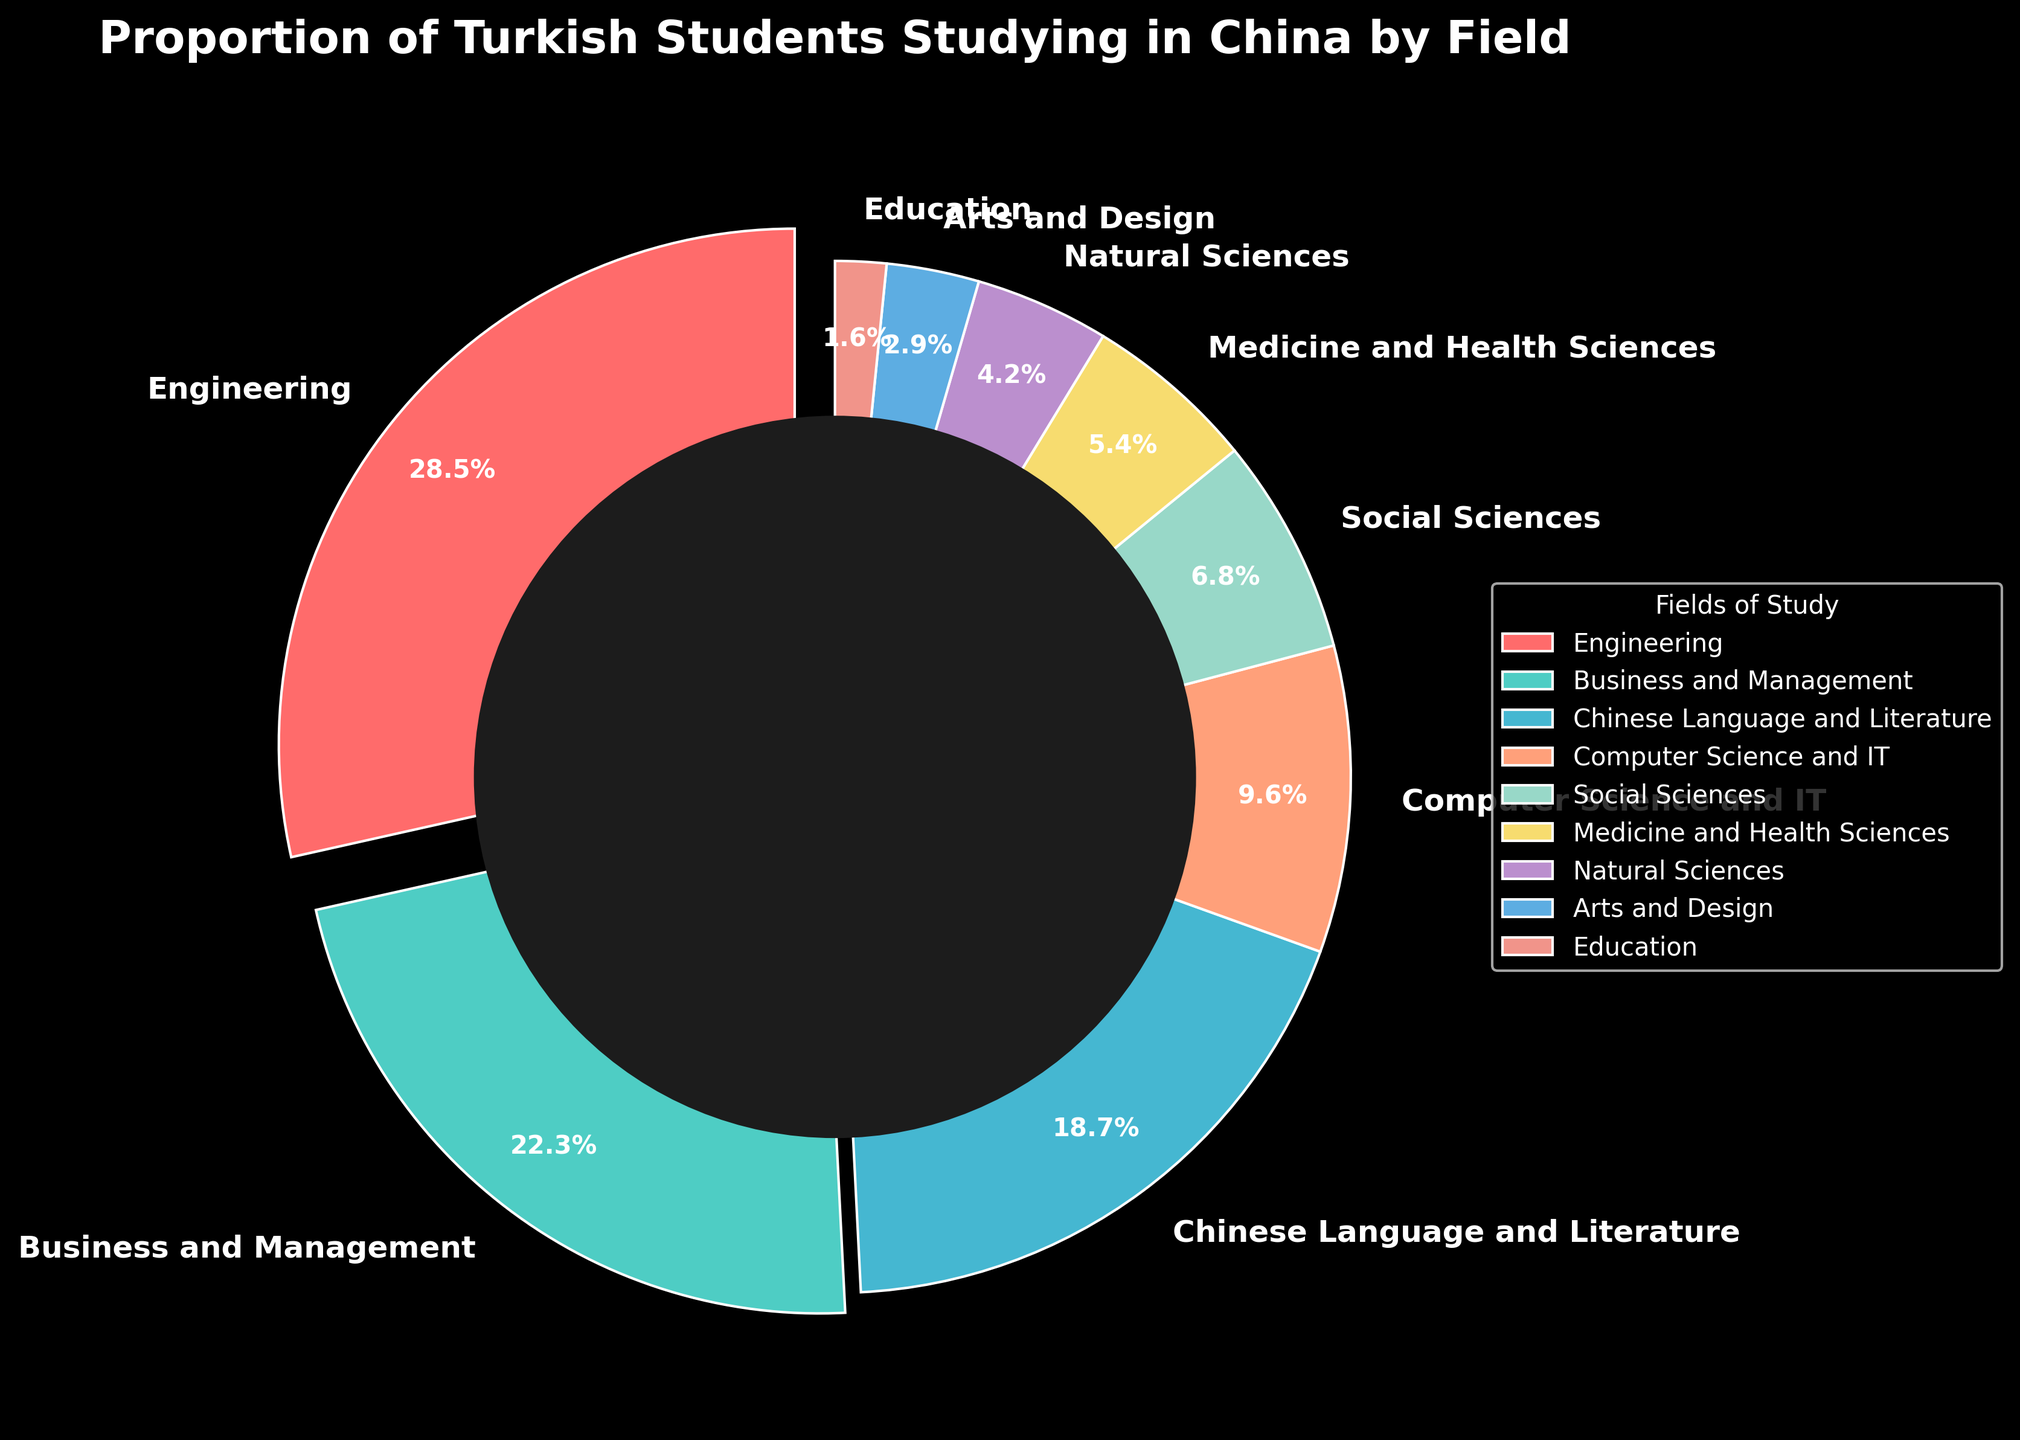Which field of study has the highest proportion of Turkish students studying in China? From the pie chart, the field with the largest wedge is labeled "Engineering" with a percentage of 28.5%.
Answer: Engineering What is the combined proportion of Turkish students studying Business and Management and Chinese Language and Literature in China? The proportions for Business and Management and Chinese Language and Literature are 22.3% and 18.7%, respectively. Adding them up: 22.3 + 18.7 = 41.0%.
Answer: 41.0% Which field has a smaller proportion of students: Medicine and Health Sciences or Social Sciences? From the pie chart, Social Sciences is 6.8% while Medicine and Health Sciences is 5.4%. Since 5.4% < 6.8%, Medicine and Health Sciences has a smaller proportion.
Answer: Medicine and Health Sciences How much larger is the proportion of students studying Engineering than the proportion studying Natural Sciences? The proportion of students in Engineering is 28.5% and in Natural Sciences is 4.2%. The difference is 28.5 - 4.2 = 24.3%.
Answer: 24.3% If a third of the students studying Engineering switched to Computer Science and IT, what would the new proportions for these two fields be? A third of Engineering's 28.5% is (1/3)*28.5 = 9.5%. Removing this from Engineering: 28.5 - 9.5 = 19.0%. Adding this to Computer Science and IT: 9.6 + 9.5 = 19.1%.
Answer: Engineering: 19.0%, Computer Science and IT: 19.1% What is the total proportion of Turkish students studying in the top three fields in China? The top three fields are Engineering (28.5%), Business and Management (22.3%), and Chinese Language and Literature (18.7%). Adding these proportions: 28.5 + 22.3 + 18.7 = 69.5%.
Answer: 69.5% Which wedge in the pie chart is displayed with a different starting angle or an additional visual effect? The largest wedge, which is Engineering, is exploded slightly outwards in the pie chart, indicating a different visual effect.
Answer: Engineering Does the proportion of students in Arts and Design exceed the proportion of students in Education by more than 1%? Arts and Design has 2.9% while Education has 1.6%. The difference is 2.9 - 1.6 = 1.3%. Since 1.3% > 1%, it exceeds by more than 1%.
Answer: Yes How many fields have a proportion of students less than 10%? From the pie chart, fields with less than 10% are: Computer Science and IT (9.6%), Social Sciences (6.8%), Medicine and Health Sciences (5.4%), Natural Sciences (4.2%), Arts and Design (2.9%), and Education (1.6%). There are 6 fields.
Answer: 6 Which field has the closest proportion to Computer Science and IT? From the pie chart, Natural Sciences has a proportion of 4.2% and Social Sciences has 6.8%. Given that Computer Science and IT is 9.6%, Social Sciences (6.8%) is the closest.
Answer: Social Sciences 